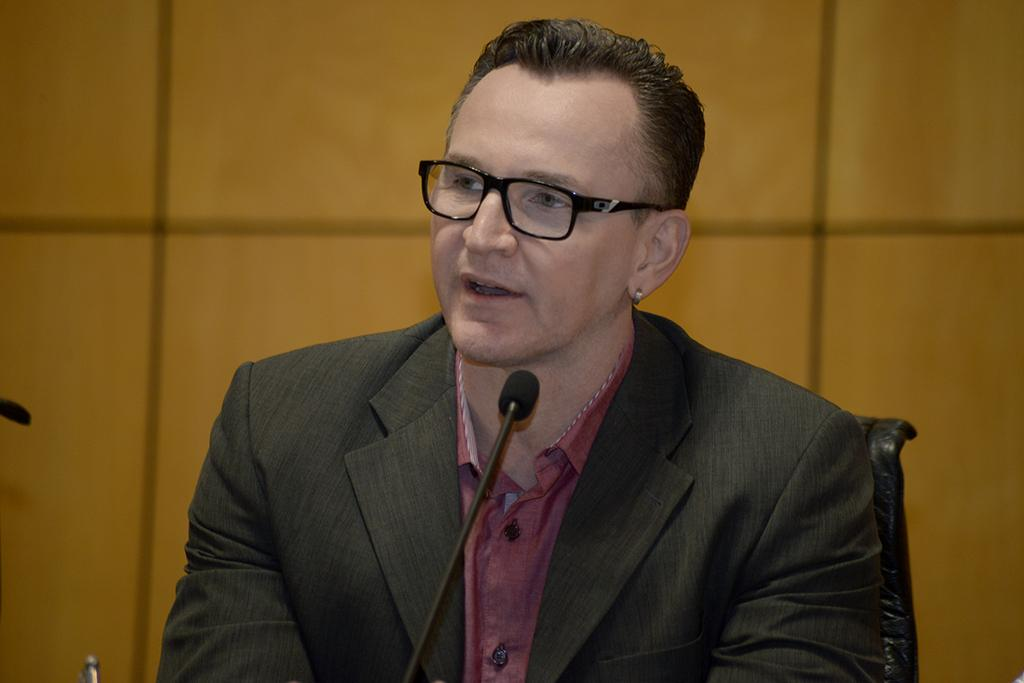What is the man in the image doing? The man is sitting in the image. What type of clothing is the man wearing? The man is wearing a suit and a shirt. What accessory is the man wearing on his face? The man is wearing a spectacle. What object is present in the image that is typically used for amplifying sound? There is a microphone in the image. What can be seen in the background of the image? There is a wall in the background of the image. What type of engine can be seen powering the man's suit in the image? There is no engine present in the image, and the man's suit is not powered by any engine. How many children are visible in the image? There are no children present in the image. 